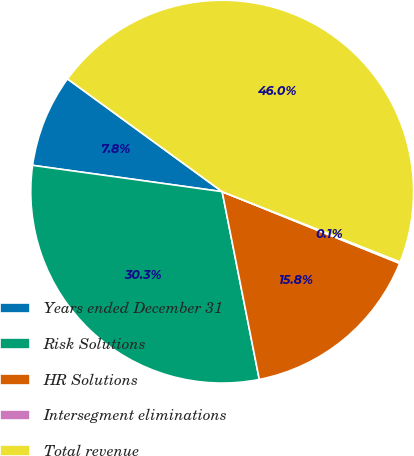<chart> <loc_0><loc_0><loc_500><loc_500><pie_chart><fcel>Years ended December 31<fcel>Risk Solutions<fcel>HR Solutions<fcel>Intersegment eliminations<fcel>Total revenue<nl><fcel>7.83%<fcel>30.3%<fcel>15.78%<fcel>0.12%<fcel>45.96%<nl></chart> 